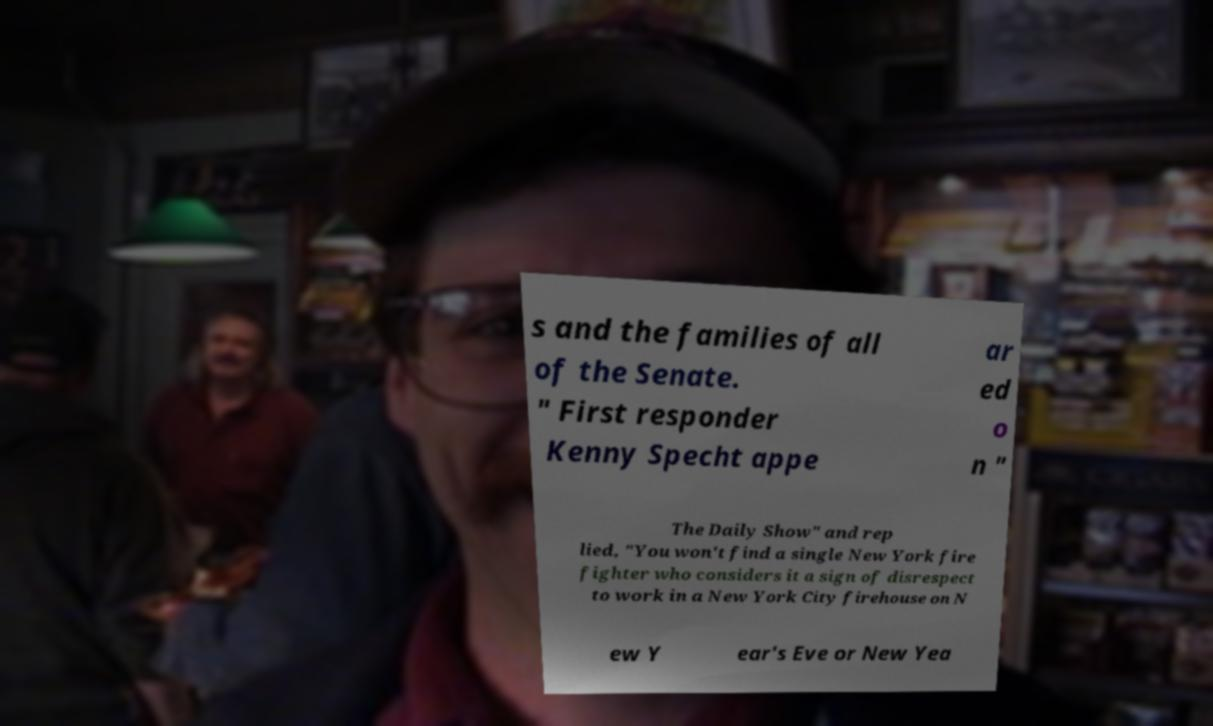Can you read and provide the text displayed in the image?This photo seems to have some interesting text. Can you extract and type it out for me? s and the families of all of the Senate. " First responder Kenny Specht appe ar ed o n " The Daily Show" and rep lied, "You won't find a single New York fire fighter who considers it a sign of disrespect to work in a New York City firehouse on N ew Y ear's Eve or New Yea 